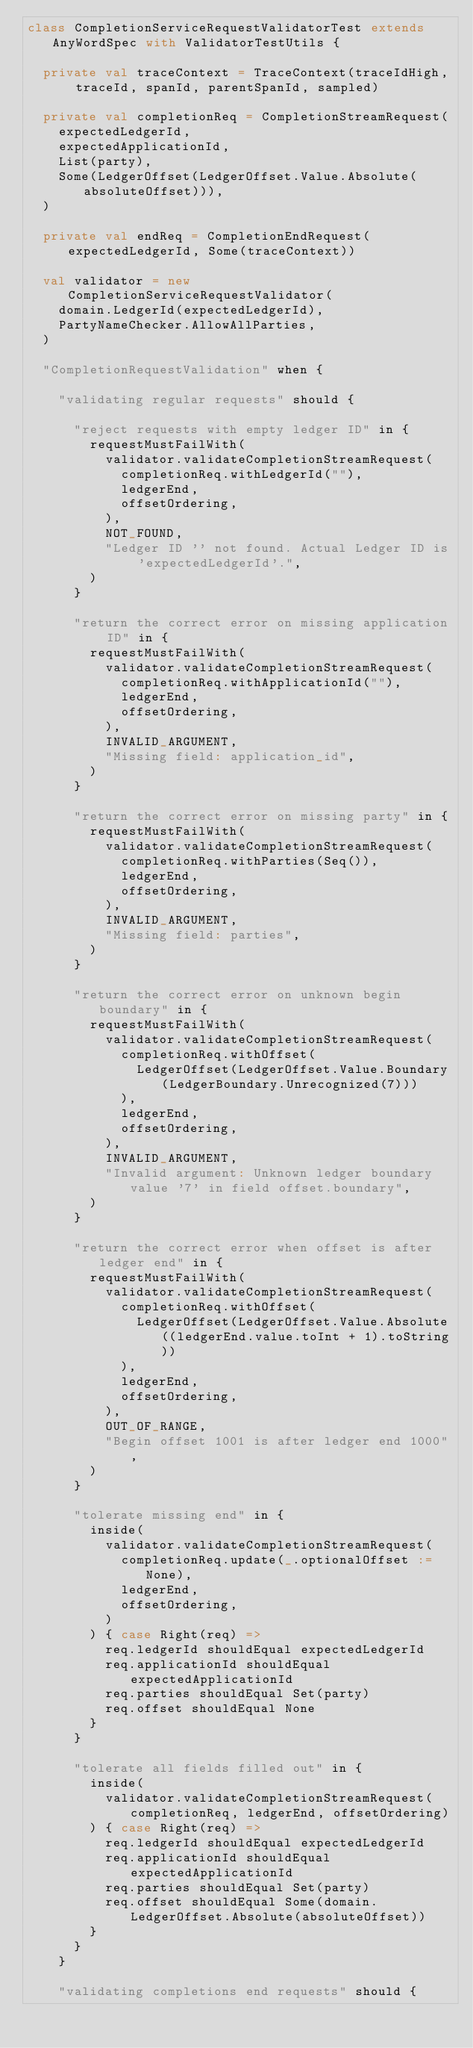<code> <loc_0><loc_0><loc_500><loc_500><_Scala_>class CompletionServiceRequestValidatorTest extends AnyWordSpec with ValidatorTestUtils {

  private val traceContext = TraceContext(traceIdHigh, traceId, spanId, parentSpanId, sampled)

  private val completionReq = CompletionStreamRequest(
    expectedLedgerId,
    expectedApplicationId,
    List(party),
    Some(LedgerOffset(LedgerOffset.Value.Absolute(absoluteOffset))),
  )

  private val endReq = CompletionEndRequest(expectedLedgerId, Some(traceContext))

  val validator = new CompletionServiceRequestValidator(
    domain.LedgerId(expectedLedgerId),
    PartyNameChecker.AllowAllParties,
  )

  "CompletionRequestValidation" when {

    "validating regular requests" should {

      "reject requests with empty ledger ID" in {
        requestMustFailWith(
          validator.validateCompletionStreamRequest(
            completionReq.withLedgerId(""),
            ledgerEnd,
            offsetOrdering,
          ),
          NOT_FOUND,
          "Ledger ID '' not found. Actual Ledger ID is 'expectedLedgerId'.",
        )
      }

      "return the correct error on missing application ID" in {
        requestMustFailWith(
          validator.validateCompletionStreamRequest(
            completionReq.withApplicationId(""),
            ledgerEnd,
            offsetOrdering,
          ),
          INVALID_ARGUMENT,
          "Missing field: application_id",
        )
      }

      "return the correct error on missing party" in {
        requestMustFailWith(
          validator.validateCompletionStreamRequest(
            completionReq.withParties(Seq()),
            ledgerEnd,
            offsetOrdering,
          ),
          INVALID_ARGUMENT,
          "Missing field: parties",
        )
      }

      "return the correct error on unknown begin boundary" in {
        requestMustFailWith(
          validator.validateCompletionStreamRequest(
            completionReq.withOffset(
              LedgerOffset(LedgerOffset.Value.Boundary(LedgerBoundary.Unrecognized(7)))
            ),
            ledgerEnd,
            offsetOrdering,
          ),
          INVALID_ARGUMENT,
          "Invalid argument: Unknown ledger boundary value '7' in field offset.boundary",
        )
      }

      "return the correct error when offset is after ledger end" in {
        requestMustFailWith(
          validator.validateCompletionStreamRequest(
            completionReq.withOffset(
              LedgerOffset(LedgerOffset.Value.Absolute((ledgerEnd.value.toInt + 1).toString))
            ),
            ledgerEnd,
            offsetOrdering,
          ),
          OUT_OF_RANGE,
          "Begin offset 1001 is after ledger end 1000",
        )
      }

      "tolerate missing end" in {
        inside(
          validator.validateCompletionStreamRequest(
            completionReq.update(_.optionalOffset := None),
            ledgerEnd,
            offsetOrdering,
          )
        ) { case Right(req) =>
          req.ledgerId shouldEqual expectedLedgerId
          req.applicationId shouldEqual expectedApplicationId
          req.parties shouldEqual Set(party)
          req.offset shouldEqual None
        }
      }

      "tolerate all fields filled out" in {
        inside(
          validator.validateCompletionStreamRequest(completionReq, ledgerEnd, offsetOrdering)
        ) { case Right(req) =>
          req.ledgerId shouldEqual expectedLedgerId
          req.applicationId shouldEqual expectedApplicationId
          req.parties shouldEqual Set(party)
          req.offset shouldEqual Some(domain.LedgerOffset.Absolute(absoluteOffset))
        }
      }
    }

    "validating completions end requests" should {
</code> 